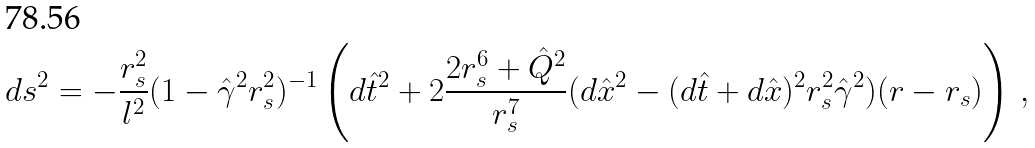<formula> <loc_0><loc_0><loc_500><loc_500>d s ^ { 2 } = - \frac { r _ { s } ^ { 2 } } { l ^ { 2 } } ( 1 - \hat { \gamma } ^ { 2 } r _ { s } ^ { 2 } ) ^ { - 1 } \left ( d \hat { t } ^ { 2 } + 2 \frac { 2 r _ { s } ^ { 6 } + \hat { Q } ^ { 2 } } { r _ { s } ^ { 7 } } ( d \hat { x } ^ { 2 } - ( d \hat { t } + d \hat { x } ) ^ { 2 } r _ { s } ^ { 2 } \hat { \gamma } ^ { 2 } ) ( r - r _ { s } ) \right ) \, ,</formula> 